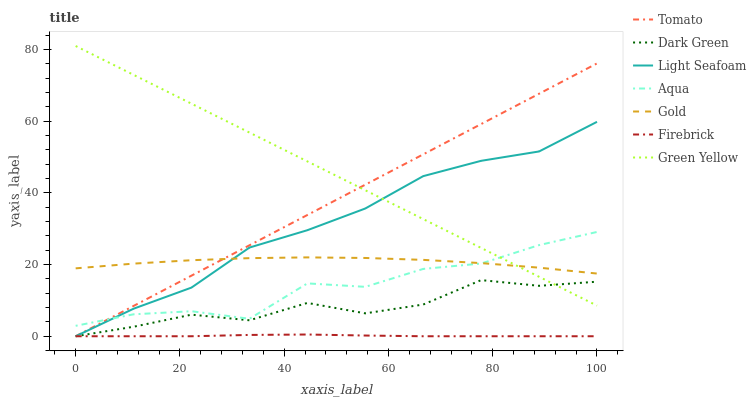Does Firebrick have the minimum area under the curve?
Answer yes or no. Yes. Does Green Yellow have the maximum area under the curve?
Answer yes or no. Yes. Does Gold have the minimum area under the curve?
Answer yes or no. No. Does Gold have the maximum area under the curve?
Answer yes or no. No. Is Tomato the smoothest?
Answer yes or no. Yes. Is Aqua the roughest?
Answer yes or no. Yes. Is Green Yellow the smoothest?
Answer yes or no. No. Is Green Yellow the roughest?
Answer yes or no. No. Does Green Yellow have the lowest value?
Answer yes or no. No. Does Green Yellow have the highest value?
Answer yes or no. Yes. Does Gold have the highest value?
Answer yes or no. No. Is Firebrick less than Aqua?
Answer yes or no. Yes. Is Gold greater than Dark Green?
Answer yes or no. Yes. Does Firebrick intersect Tomato?
Answer yes or no. Yes. Is Firebrick less than Tomato?
Answer yes or no. No. Is Firebrick greater than Tomato?
Answer yes or no. No. Does Firebrick intersect Aqua?
Answer yes or no. No. 